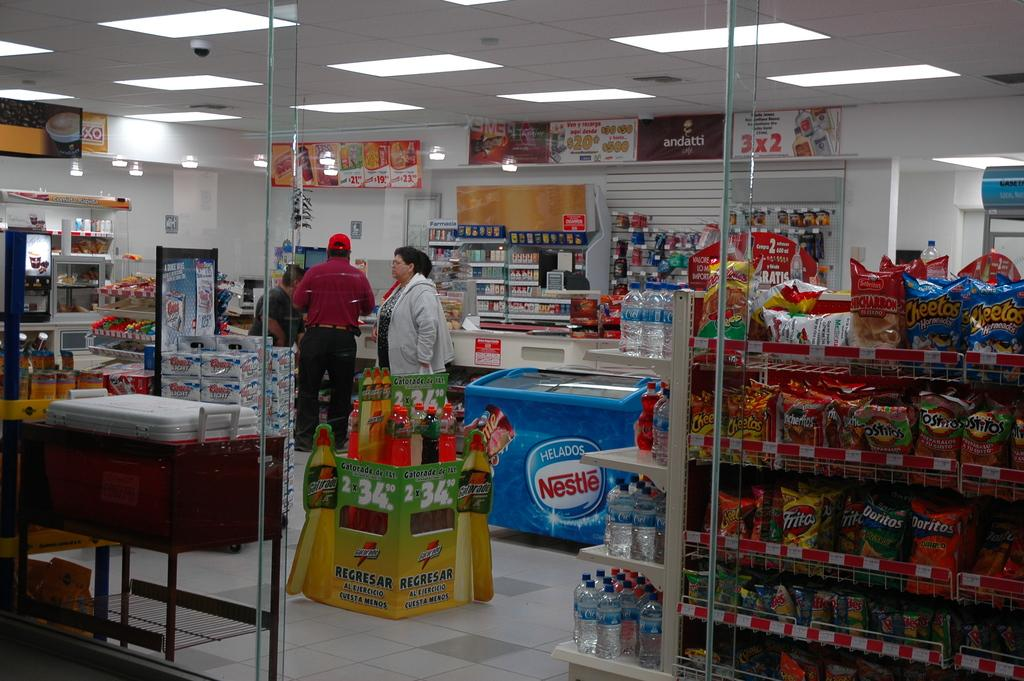<image>
Describe the image concisely. Store that has a freezer which sells Nestle products. 